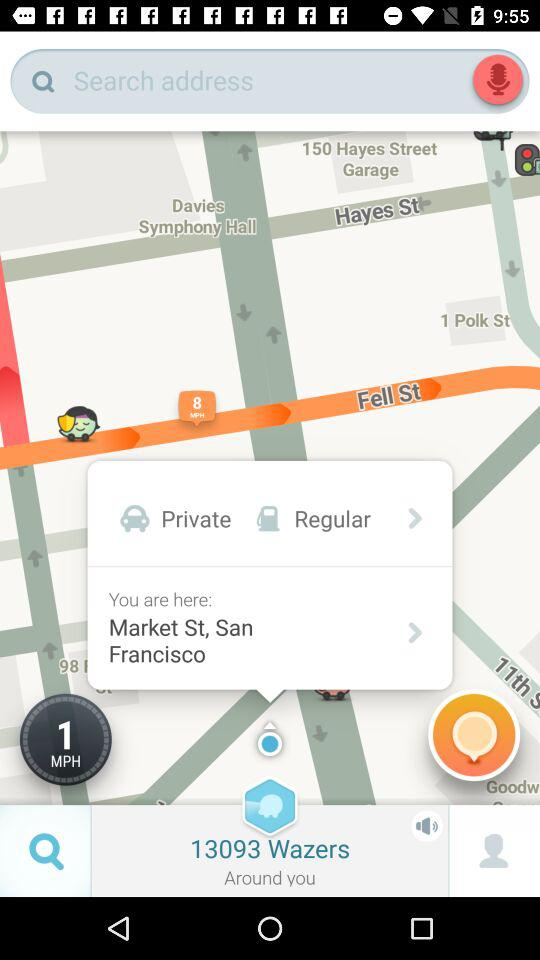What is the speed? The speed is 1 mph. 